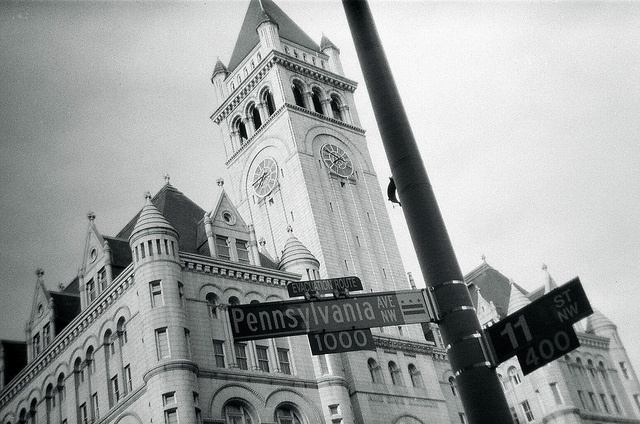Describe the objects in this image and their specific colors. I can see clock in gray, darkgray, lightgray, and black tones and clock in gray, darkgray, lightgray, and black tones in this image. 